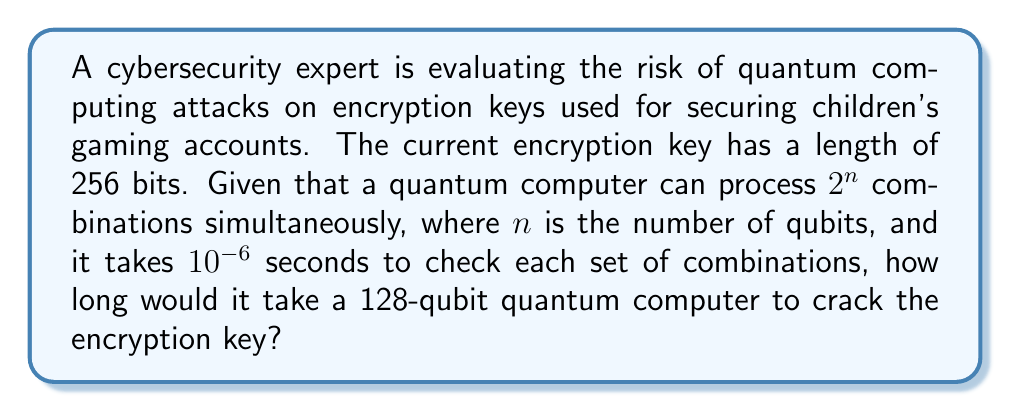Show me your answer to this math problem. To solve this problem, we need to follow these steps:

1. Calculate the total number of possible combinations for a 256-bit key:
   $$\text{Total combinations} = 2^{256}$$

2. Determine how many combinations the quantum computer can process in one iteration:
   $$\text{Combinations per iteration} = 2^{128}$$ (since it's a 128-qubit computer)

3. Calculate the number of iterations required:
   $$\text{Iterations} = \frac{\text{Total combinations}}{\text{Combinations per iteration}} = \frac{2^{256}}{2^{128}} = 2^{128}$$

4. Calculate the time taken for one iteration:
   $$\text{Time per iteration} = 10^{-6} \text{ seconds}$$

5. Calculate the total time:
   $$\text{Total time} = \text{Iterations} \times \text{Time per iteration} = 2^{128} \times 10^{-6} \text{ seconds}$$

6. Convert the result to years:
   $$\text{Time in years} = \frac{2^{128} \times 10^{-6}}{60 \times 60 \times 24 \times 365.25}$$

Simplifying:
$$\text{Time in years} \approx 3.4 \times 10^{22} \text{ years}$$

This is an extremely long time, far exceeding the age of the universe, which demonstrates the current strength of 256-bit encryption against quantum computing attacks.
Answer: Approximately $3.4 \times 10^{22}$ years 